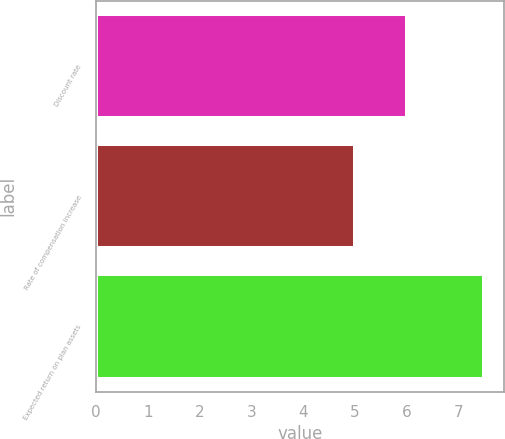<chart> <loc_0><loc_0><loc_500><loc_500><bar_chart><fcel>Discount rate<fcel>Rate of compensation increase<fcel>Expected return on plan assets<nl><fcel>6<fcel>5<fcel>7.5<nl></chart> 